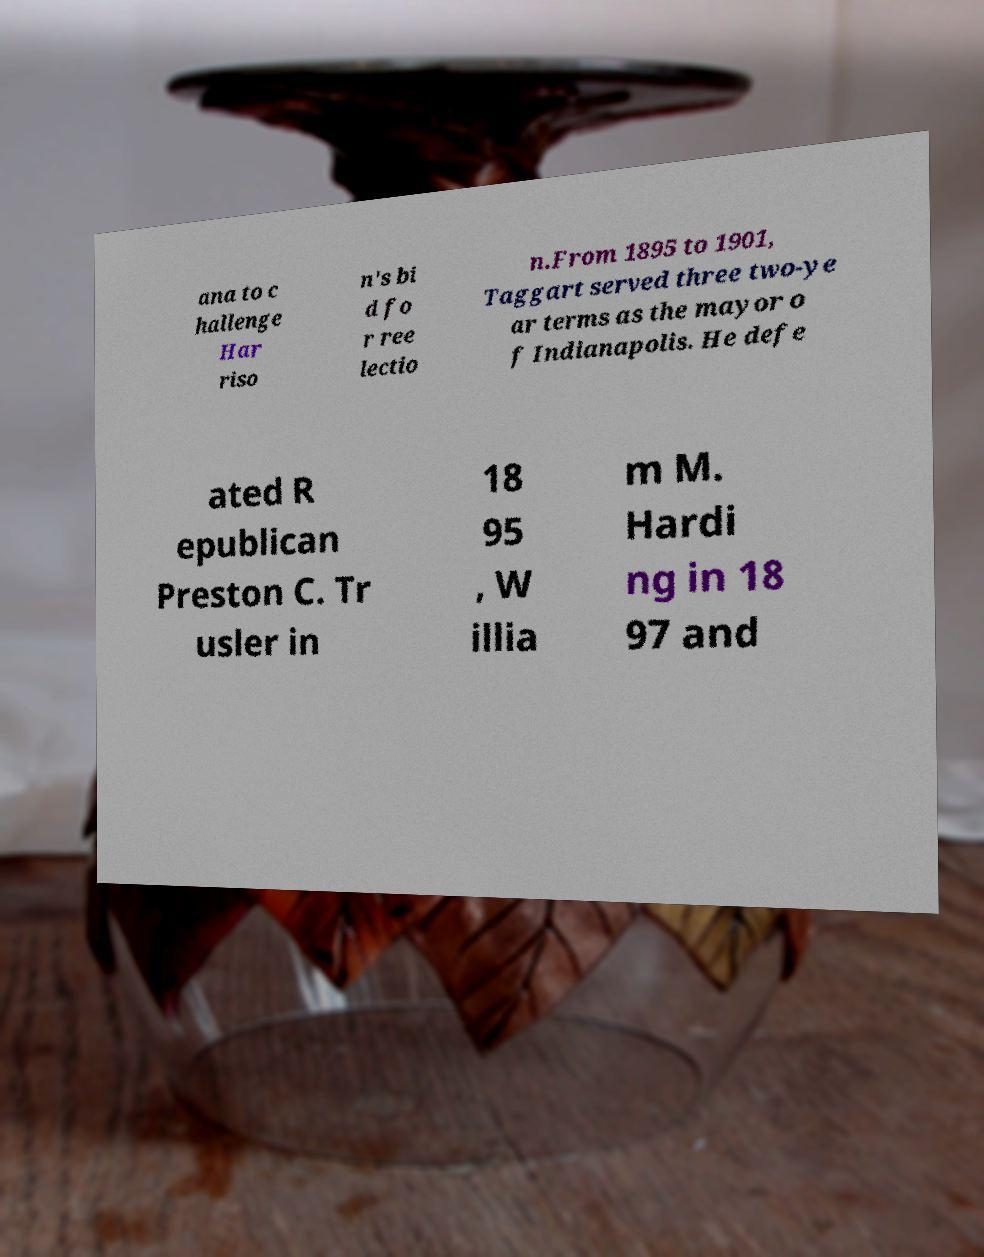What messages or text are displayed in this image? I need them in a readable, typed format. ana to c hallenge Har riso n's bi d fo r ree lectio n.From 1895 to 1901, Taggart served three two-ye ar terms as the mayor o f Indianapolis. He defe ated R epublican Preston C. Tr usler in 18 95 , W illia m M. Hardi ng in 18 97 and 